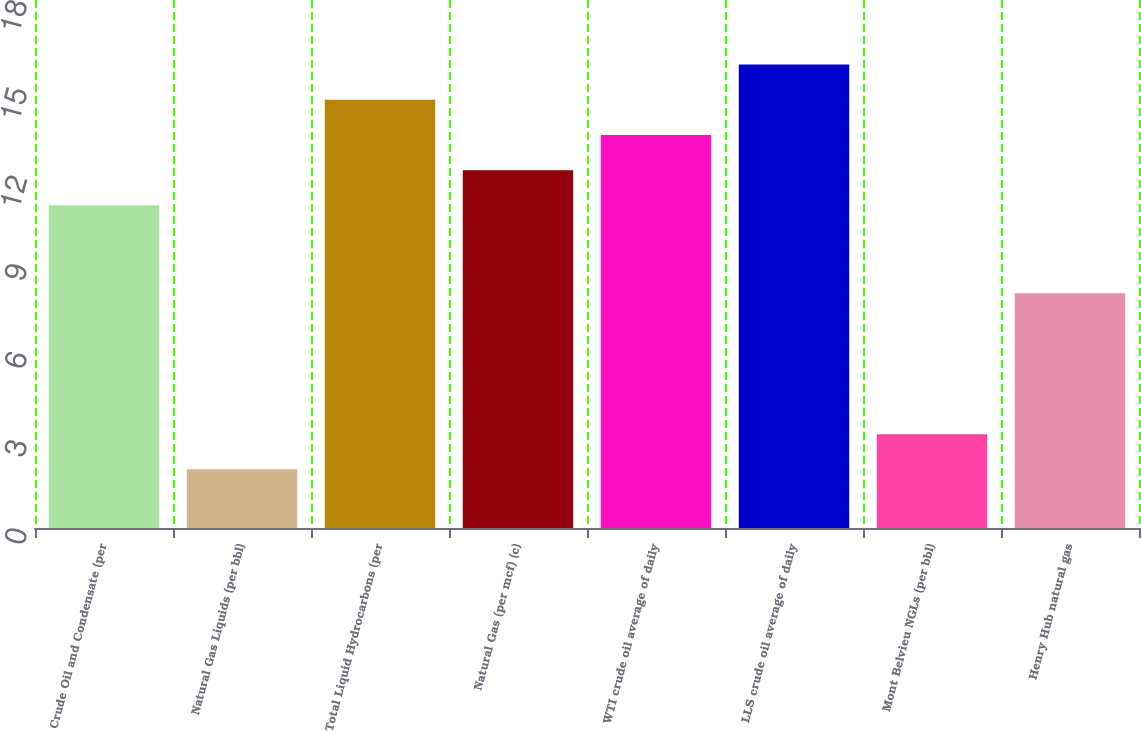Convert chart to OTSL. <chart><loc_0><loc_0><loc_500><loc_500><bar_chart><fcel>Crude Oil and Condensate (per<fcel>Natural Gas Liquids (per bbl)<fcel>Total Liquid Hydrocarbons (per<fcel>Natural Gas (per mcf) (c)<fcel>WTI crude oil average of daily<fcel>LLS crude oil average of daily<fcel>Mont Belvieu NGLs (per bbl)<fcel>Henry Hub natural gas<nl><fcel>11<fcel>2<fcel>14.6<fcel>12.2<fcel>13.4<fcel>15.8<fcel>3.2<fcel>8<nl></chart> 